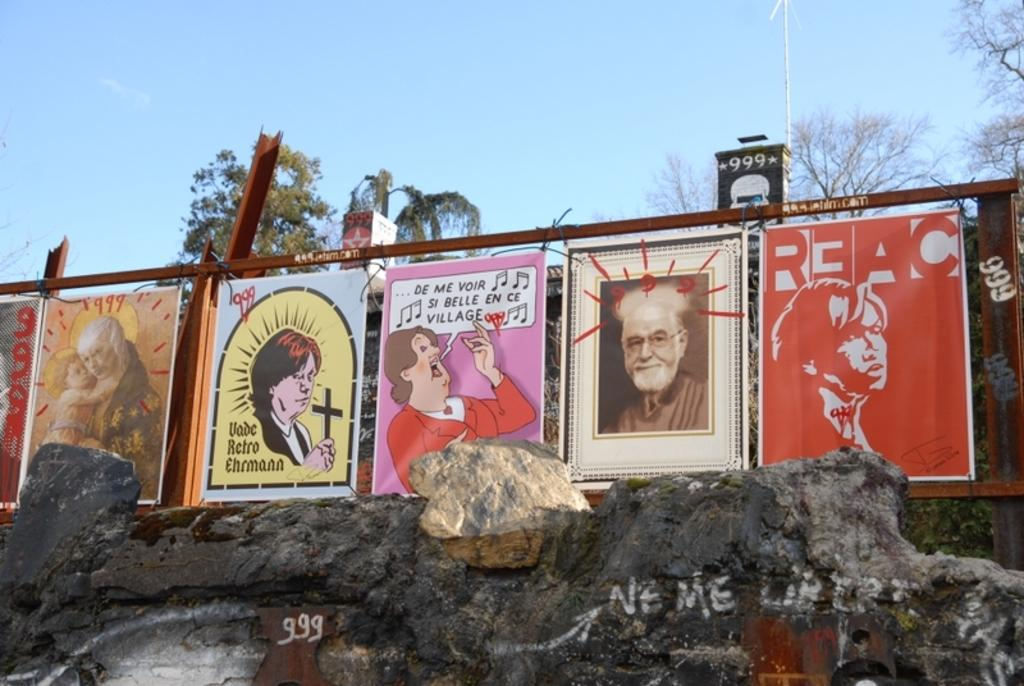What can be seen extending from left to right in the image? There are posts in the image, extending from left to right. What is visible in the background of the image? There are rocks and trees in the background of the image. What color is the sky in the image? The sky is blue in color. How many rings are being exchanged in the image? There are no rings or any indication of an exchange in the image. 